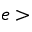<formula> <loc_0><loc_0><loc_500><loc_500>e ></formula> 